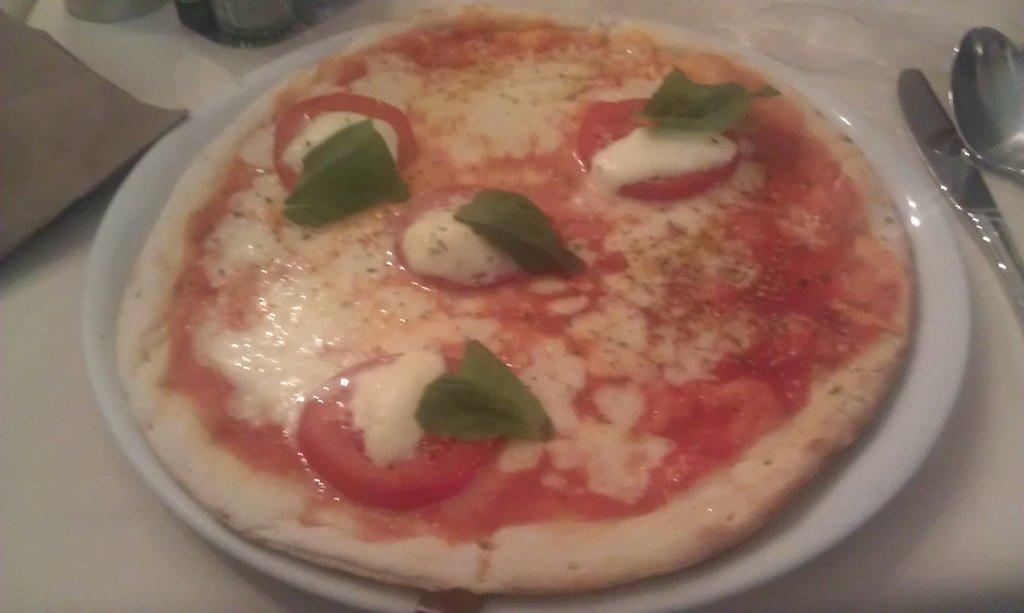Could you give a brief overview of what you see in this image? In this image we can find food item on the plate, and there are four tomato slices, and four leaves on it, beside to it there is a spoon and a knife. 